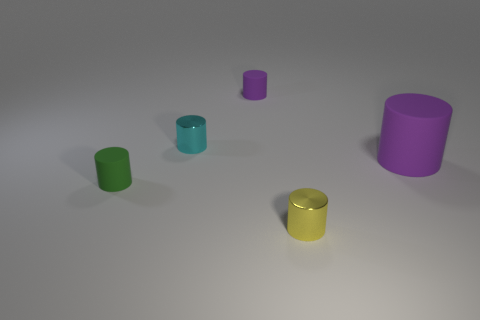Subtract all red spheres. How many purple cylinders are left? 2 Add 2 cylinders. How many objects exist? 7 Subtract all big purple cylinders. How many cylinders are left? 4 Subtract all purple cylinders. How many cylinders are left? 3 Subtract 2 cylinders. How many cylinders are left? 3 Subtract all brown cylinders. Subtract all brown spheres. How many cylinders are left? 5 Subtract all tiny shiny spheres. Subtract all tiny cylinders. How many objects are left? 1 Add 2 purple rubber cylinders. How many purple rubber cylinders are left? 4 Add 2 yellow things. How many yellow things exist? 3 Subtract 1 cyan cylinders. How many objects are left? 4 